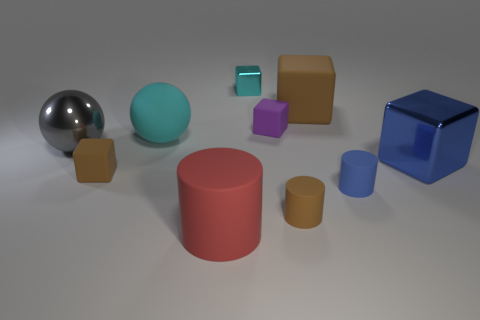Which object seems out of place in this collection, given the color and material themes? The shiny blue cube appears out of place because its reflective surface and intense color contrast with the more subdued matte textures and colors of the other objects in the image. 